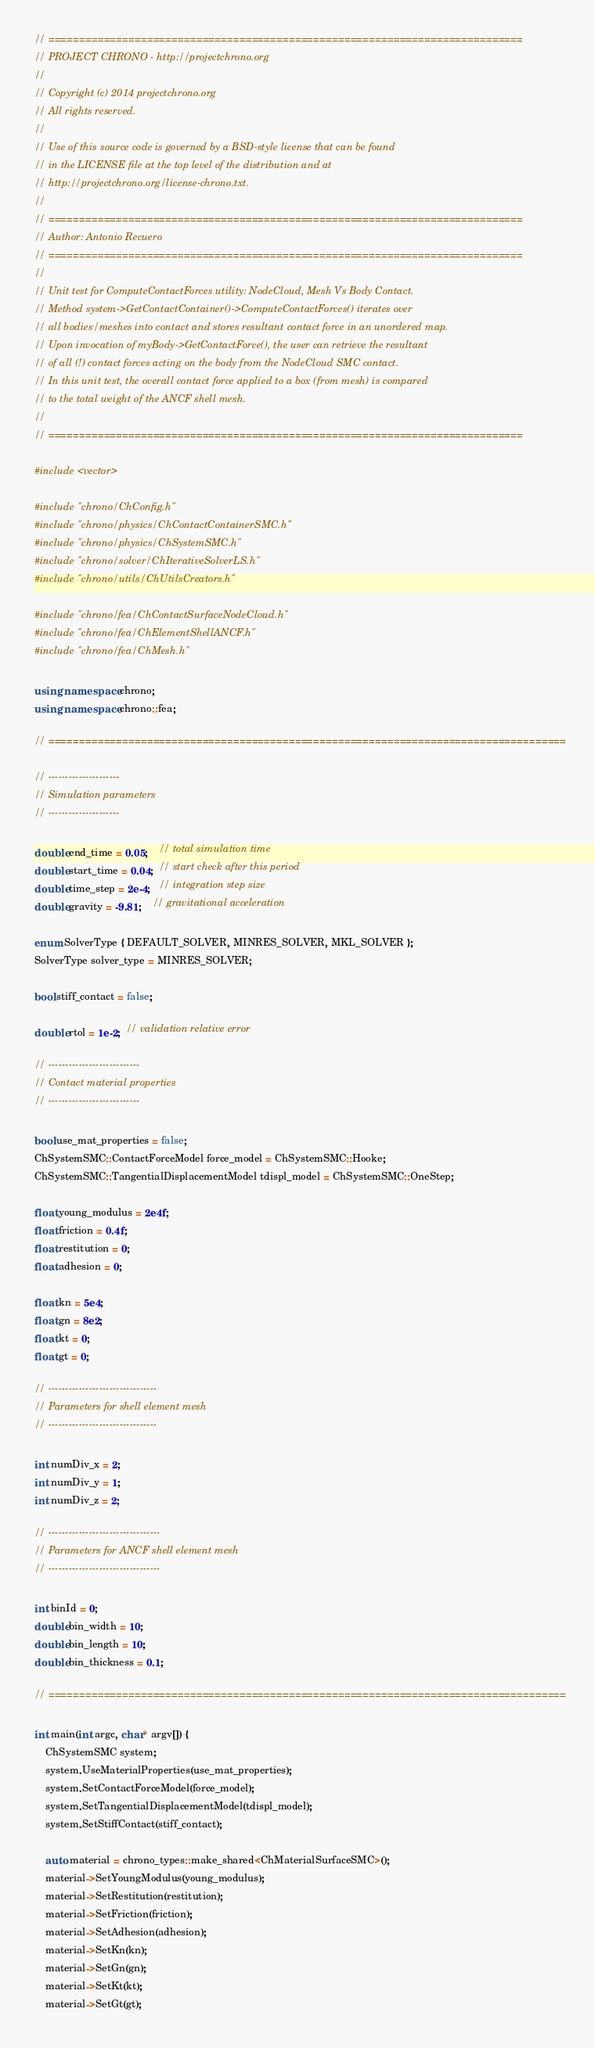<code> <loc_0><loc_0><loc_500><loc_500><_C++_>// =============================================================================
// PROJECT CHRONO - http://projectchrono.org
//
// Copyright (c) 2014 projectchrono.org
// All rights reserved.
//
// Use of this source code is governed by a BSD-style license that can be found
// in the LICENSE file at the top level of the distribution and at
// http://projectchrono.org/license-chrono.txt.
//
// =============================================================================
// Author: Antonio Recuero
// =============================================================================
//
// Unit test for ComputeContactForces utility: NodeCloud, Mesh Vs Body Contact.
// Method system->GetContactContainer()->ComputeContactForces() iterates over
// all bodies/meshes into contact and stores resultant contact force in an unordered map.
// Upon invocation of myBody->GetContactForce(), the user can retrieve the resultant
// of all (!) contact forces acting on the body from the NodeCloud SMC contact.
// In this unit test, the overall contact force applied to a box (from mesh) is compared
// to the total weight of the ANCF shell mesh.
//
// =============================================================================

#include <vector>

#include "chrono/ChConfig.h"
#include "chrono/physics/ChContactContainerSMC.h"
#include "chrono/physics/ChSystemSMC.h"
#include "chrono/solver/ChIterativeSolverLS.h"
#include "chrono/utils/ChUtilsCreators.h"

#include "chrono/fea/ChContactSurfaceNodeCloud.h"
#include "chrono/fea/ChElementShellANCF.h"
#include "chrono/fea/ChMesh.h"

using namespace chrono;
using namespace chrono::fea;

// ====================================================================================

// ---------------------
// Simulation parameters
// ---------------------

double end_time = 0.05;    // total simulation time
double start_time = 0.04;  // start check after this period
double time_step = 2e-4;   // integration step size
double gravity = -9.81;    // gravitational acceleration

enum SolverType { DEFAULT_SOLVER, MINRES_SOLVER, MKL_SOLVER };
SolverType solver_type = MINRES_SOLVER;

bool stiff_contact = false;

double rtol = 1e-2;  // validation relative error

// ---------------------------
// Contact material properties
// ---------------------------

bool use_mat_properties = false;
ChSystemSMC::ContactForceModel force_model = ChSystemSMC::Hooke;
ChSystemSMC::TangentialDisplacementModel tdispl_model = ChSystemSMC::OneStep;

float young_modulus = 2e4f;
float friction = 0.4f;
float restitution = 0;
float adhesion = 0;

float kn = 5e4;
float gn = 8e2;
float kt = 0;
float gt = 0;

// --------------------------------
// Parameters for shell element mesh
// --------------------------------

int numDiv_x = 2;
int numDiv_y = 1;
int numDiv_z = 2;

// ---------------------------------
// Parameters for ANCF shell element mesh
// ---------------------------------

int binId = 0;
double bin_width = 10;
double bin_length = 10;
double bin_thickness = 0.1;

// ====================================================================================

int main(int argc, char* argv[]) {
    ChSystemSMC system;
    system.UseMaterialProperties(use_mat_properties);
    system.SetContactForceModel(force_model);
    system.SetTangentialDisplacementModel(tdispl_model);
    system.SetStiffContact(stiff_contact);

    auto material = chrono_types::make_shared<ChMaterialSurfaceSMC>();
    material->SetYoungModulus(young_modulus);
    material->SetRestitution(restitution);
    material->SetFriction(friction);
    material->SetAdhesion(adhesion);
    material->SetKn(kn);
    material->SetGn(gn);
    material->SetKt(kt);
    material->SetGt(gt);
</code> 